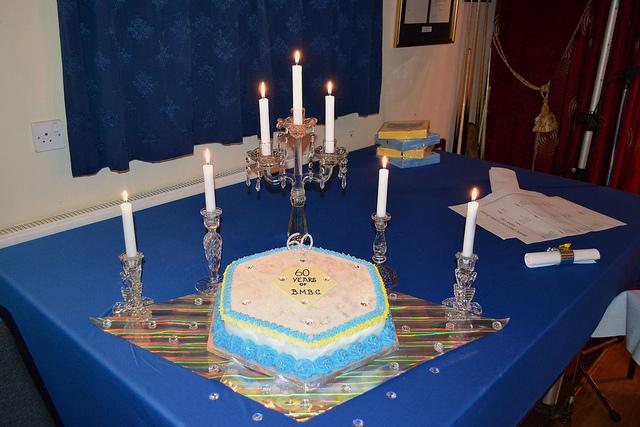Is this an artificial birthday cake?
Answer briefly. No. How many candles are in this picture?
Quick response, please. 7. Could someone be having a birthday?
Keep it brief. Yes. How many pieces of paper are on the table?
Answer briefly. 2. 